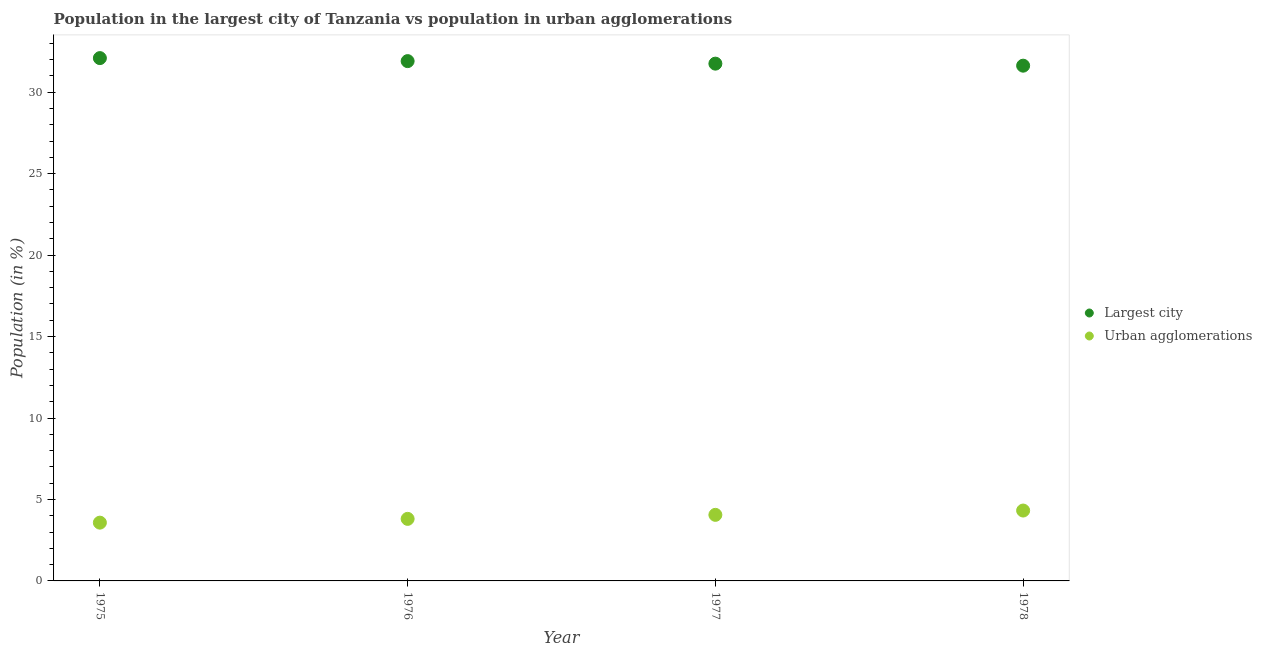How many different coloured dotlines are there?
Keep it short and to the point. 2. Is the number of dotlines equal to the number of legend labels?
Give a very brief answer. Yes. What is the population in urban agglomerations in 1976?
Offer a very short reply. 3.81. Across all years, what is the maximum population in the largest city?
Your response must be concise. 32.09. Across all years, what is the minimum population in the largest city?
Your response must be concise. 31.63. In which year was the population in the largest city maximum?
Your answer should be compact. 1975. In which year was the population in urban agglomerations minimum?
Provide a short and direct response. 1975. What is the total population in the largest city in the graph?
Keep it short and to the point. 127.37. What is the difference between the population in the largest city in 1977 and that in 1978?
Ensure brevity in your answer.  0.12. What is the difference between the population in urban agglomerations in 1978 and the population in the largest city in 1977?
Provide a short and direct response. -27.43. What is the average population in the largest city per year?
Provide a short and direct response. 31.84. In the year 1977, what is the difference between the population in urban agglomerations and population in the largest city?
Give a very brief answer. -27.7. In how many years, is the population in urban agglomerations greater than 7 %?
Provide a succinct answer. 0. What is the ratio of the population in urban agglomerations in 1976 to that in 1977?
Your answer should be compact. 0.94. What is the difference between the highest and the second highest population in urban agglomerations?
Ensure brevity in your answer.  0.26. What is the difference between the highest and the lowest population in urban agglomerations?
Your answer should be compact. 0.74. In how many years, is the population in urban agglomerations greater than the average population in urban agglomerations taken over all years?
Provide a succinct answer. 2. Does the population in the largest city monotonically increase over the years?
Ensure brevity in your answer.  No. Is the population in urban agglomerations strictly less than the population in the largest city over the years?
Provide a short and direct response. Yes. How many dotlines are there?
Make the answer very short. 2. How many years are there in the graph?
Offer a terse response. 4. Are the values on the major ticks of Y-axis written in scientific E-notation?
Keep it short and to the point. No. Does the graph contain any zero values?
Provide a succinct answer. No. Where does the legend appear in the graph?
Offer a terse response. Center right. How are the legend labels stacked?
Keep it short and to the point. Vertical. What is the title of the graph?
Your response must be concise. Population in the largest city of Tanzania vs population in urban agglomerations. Does "Domestic liabilities" appear as one of the legend labels in the graph?
Your answer should be compact. No. What is the Population (in %) in Largest city in 1975?
Offer a very short reply. 32.09. What is the Population (in %) in Urban agglomerations in 1975?
Ensure brevity in your answer.  3.58. What is the Population (in %) in Largest city in 1976?
Offer a very short reply. 31.91. What is the Population (in %) in Urban agglomerations in 1976?
Your answer should be very brief. 3.81. What is the Population (in %) in Largest city in 1977?
Provide a short and direct response. 31.75. What is the Population (in %) of Urban agglomerations in 1977?
Provide a short and direct response. 4.06. What is the Population (in %) of Largest city in 1978?
Your response must be concise. 31.63. What is the Population (in %) in Urban agglomerations in 1978?
Provide a short and direct response. 4.32. Across all years, what is the maximum Population (in %) of Largest city?
Provide a short and direct response. 32.09. Across all years, what is the maximum Population (in %) of Urban agglomerations?
Keep it short and to the point. 4.32. Across all years, what is the minimum Population (in %) in Largest city?
Your answer should be very brief. 31.63. Across all years, what is the minimum Population (in %) of Urban agglomerations?
Offer a terse response. 3.58. What is the total Population (in %) in Largest city in the graph?
Ensure brevity in your answer.  127.37. What is the total Population (in %) of Urban agglomerations in the graph?
Offer a terse response. 15.76. What is the difference between the Population (in %) in Largest city in 1975 and that in 1976?
Provide a succinct answer. 0.18. What is the difference between the Population (in %) of Urban agglomerations in 1975 and that in 1976?
Make the answer very short. -0.23. What is the difference between the Population (in %) of Largest city in 1975 and that in 1977?
Your answer should be very brief. 0.34. What is the difference between the Population (in %) of Urban agglomerations in 1975 and that in 1977?
Your response must be concise. -0.48. What is the difference between the Population (in %) in Largest city in 1975 and that in 1978?
Make the answer very short. 0.46. What is the difference between the Population (in %) in Urban agglomerations in 1975 and that in 1978?
Your answer should be compact. -0.74. What is the difference between the Population (in %) of Largest city in 1976 and that in 1977?
Offer a very short reply. 0.16. What is the difference between the Population (in %) in Urban agglomerations in 1976 and that in 1977?
Give a very brief answer. -0.25. What is the difference between the Population (in %) in Largest city in 1976 and that in 1978?
Provide a succinct answer. 0.28. What is the difference between the Population (in %) in Urban agglomerations in 1976 and that in 1978?
Your answer should be compact. -0.51. What is the difference between the Population (in %) in Largest city in 1977 and that in 1978?
Make the answer very short. 0.12. What is the difference between the Population (in %) of Urban agglomerations in 1977 and that in 1978?
Your answer should be compact. -0.26. What is the difference between the Population (in %) of Largest city in 1975 and the Population (in %) of Urban agglomerations in 1976?
Make the answer very short. 28.28. What is the difference between the Population (in %) of Largest city in 1975 and the Population (in %) of Urban agglomerations in 1977?
Keep it short and to the point. 28.04. What is the difference between the Population (in %) of Largest city in 1975 and the Population (in %) of Urban agglomerations in 1978?
Give a very brief answer. 27.77. What is the difference between the Population (in %) in Largest city in 1976 and the Population (in %) in Urban agglomerations in 1977?
Give a very brief answer. 27.85. What is the difference between the Population (in %) in Largest city in 1976 and the Population (in %) in Urban agglomerations in 1978?
Provide a succinct answer. 27.59. What is the difference between the Population (in %) in Largest city in 1977 and the Population (in %) in Urban agglomerations in 1978?
Provide a short and direct response. 27.43. What is the average Population (in %) in Largest city per year?
Provide a short and direct response. 31.84. What is the average Population (in %) in Urban agglomerations per year?
Offer a very short reply. 3.94. In the year 1975, what is the difference between the Population (in %) of Largest city and Population (in %) of Urban agglomerations?
Provide a short and direct response. 28.51. In the year 1976, what is the difference between the Population (in %) of Largest city and Population (in %) of Urban agglomerations?
Offer a terse response. 28.1. In the year 1977, what is the difference between the Population (in %) of Largest city and Population (in %) of Urban agglomerations?
Ensure brevity in your answer.  27.7. In the year 1978, what is the difference between the Population (in %) in Largest city and Population (in %) in Urban agglomerations?
Make the answer very short. 27.31. What is the ratio of the Population (in %) in Largest city in 1975 to that in 1976?
Keep it short and to the point. 1.01. What is the ratio of the Population (in %) of Urban agglomerations in 1975 to that in 1976?
Make the answer very short. 0.94. What is the ratio of the Population (in %) of Largest city in 1975 to that in 1977?
Your response must be concise. 1.01. What is the ratio of the Population (in %) of Urban agglomerations in 1975 to that in 1977?
Offer a terse response. 0.88. What is the ratio of the Population (in %) in Largest city in 1975 to that in 1978?
Ensure brevity in your answer.  1.01. What is the ratio of the Population (in %) of Urban agglomerations in 1975 to that in 1978?
Make the answer very short. 0.83. What is the ratio of the Population (in %) in Urban agglomerations in 1976 to that in 1977?
Give a very brief answer. 0.94. What is the ratio of the Population (in %) in Largest city in 1976 to that in 1978?
Make the answer very short. 1.01. What is the ratio of the Population (in %) of Urban agglomerations in 1976 to that in 1978?
Your answer should be very brief. 0.88. What is the ratio of the Population (in %) in Largest city in 1977 to that in 1978?
Ensure brevity in your answer.  1. What is the ratio of the Population (in %) of Urban agglomerations in 1977 to that in 1978?
Ensure brevity in your answer.  0.94. What is the difference between the highest and the second highest Population (in %) of Largest city?
Ensure brevity in your answer.  0.18. What is the difference between the highest and the second highest Population (in %) in Urban agglomerations?
Your response must be concise. 0.26. What is the difference between the highest and the lowest Population (in %) in Largest city?
Ensure brevity in your answer.  0.46. What is the difference between the highest and the lowest Population (in %) in Urban agglomerations?
Your answer should be compact. 0.74. 